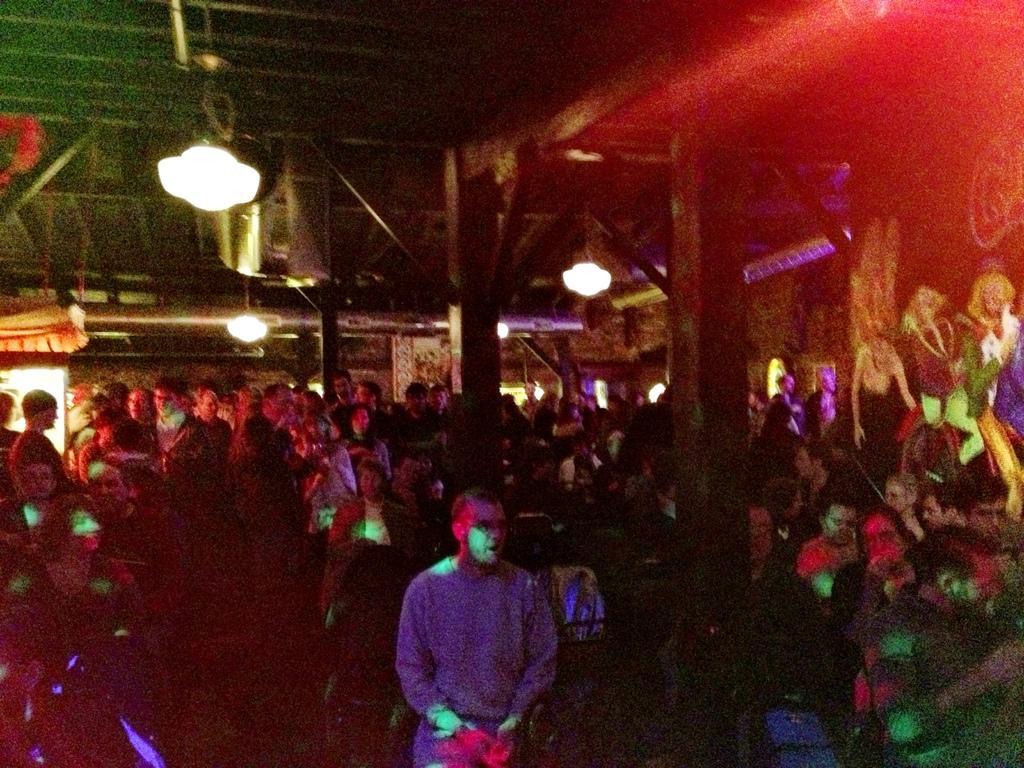Please provide a concise description of this image. In this picture we can see many people. There is a painting of few people on the right side. We can see some lights on top. There is a stall in the background. 